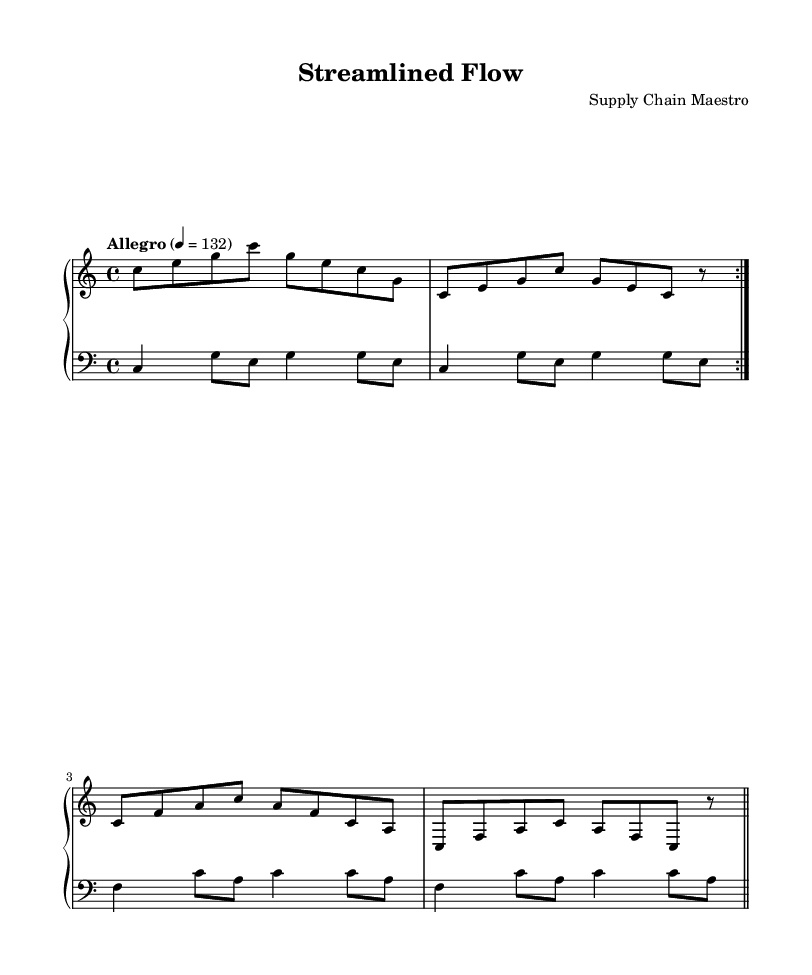What is the key signature of this music? The key signature is indicated at the beginning of the music staff, which shows no sharps or flats, indicating that it is in C major.
Answer: C major What is the time signature of this composition? The time signature is shown at the beginning of the staff, represented as "4/4", meaning there are four beats in a measure and a quarter note receives one beat.
Answer: 4/4 What is the tempo marking of this piece? The tempo marking is noted in the score as "Allegro" with a metronome marking of 132, indicating a fast pace for performance.
Answer: Allegro, 132 How many measures are in the right hand part before the repeat? The right hand part features two sections, each with four measures before repeating, so there are a total of 8 measures before the repeat sign.
Answer: 8 What does the left hand use in its harmonic structure? The left hand primarily utilizes fifths and octaves in its progression, which can be identified as it plays combinations of notes that create these intervals.
Answer: Fifths and octaves How many times do the right and left hand repeat their respective phrases? Both the right and left hand have a repeat indication ("volta 2"), meaning each hand plays its section twice before moving on.
Answer: Twice What is the general style of the composition? The composition is minimalist in style, characterized by its streamlined melodic and harmonic structures, reflecting simplicity and efficiency in musical form.
Answer: Minimalist 